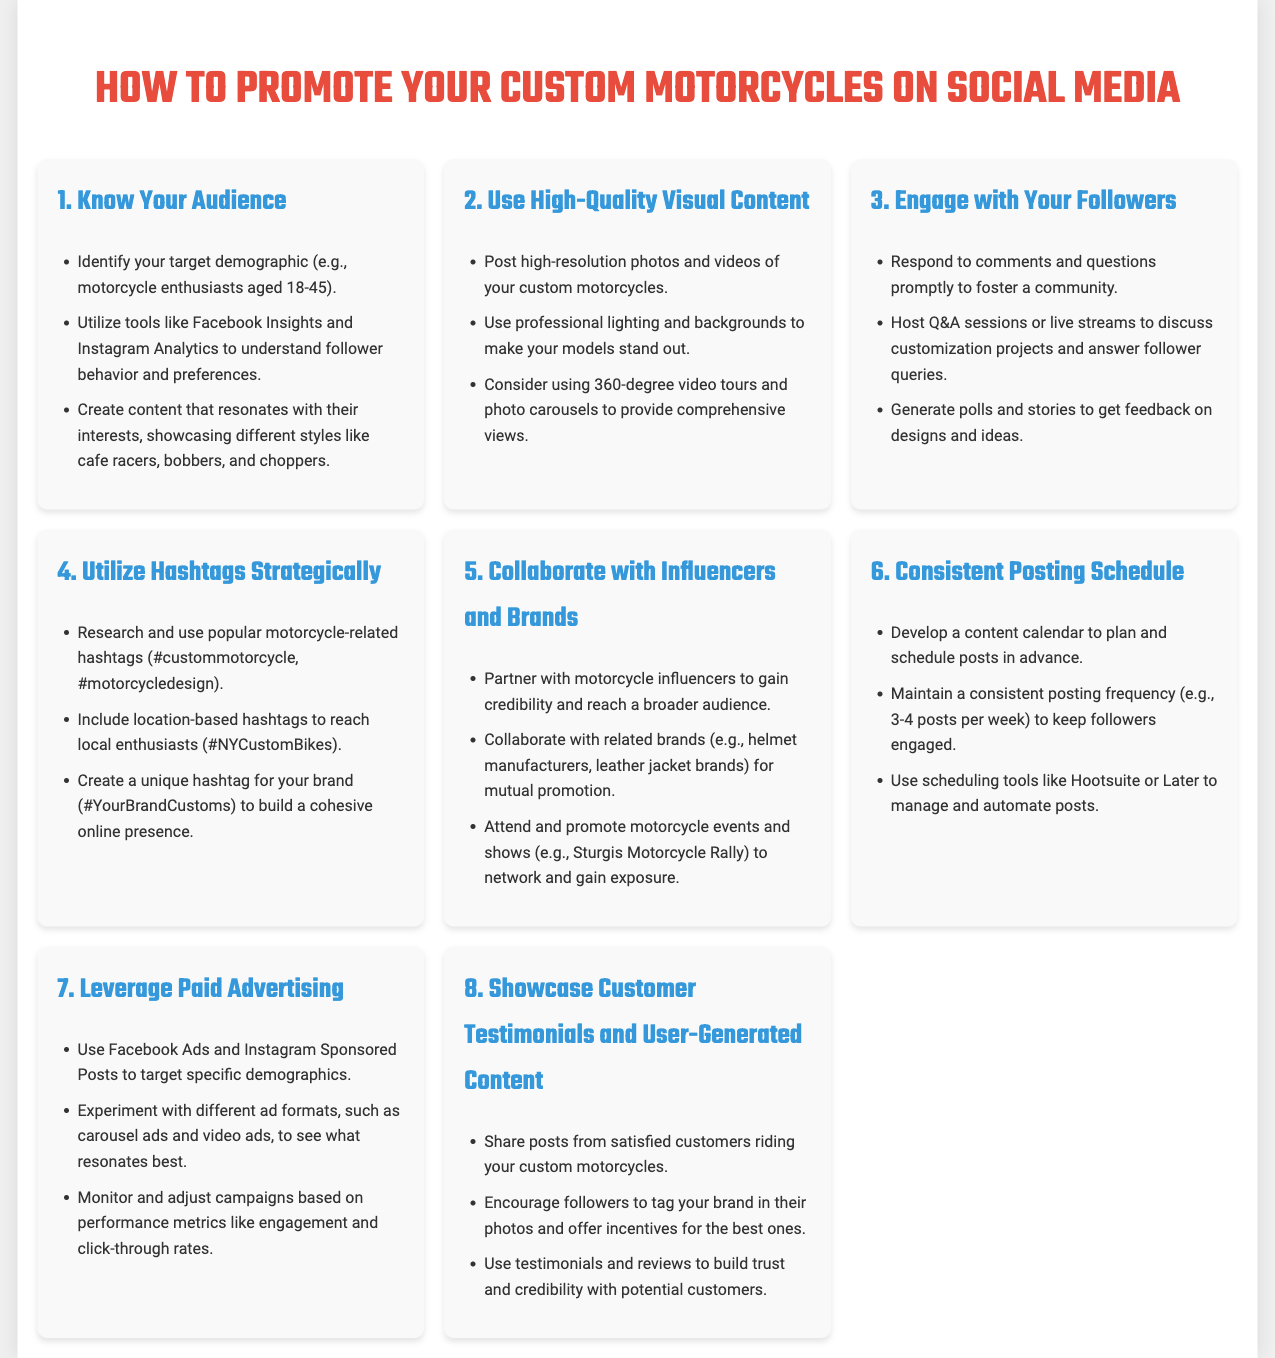What is the first step in promoting custom motorcycles? The first step in the infographic is to "Know Your Audience."
Answer: Know Your Audience How many posts per week does the document recommend for consistent posting? The document suggests maintaining a consistent posting frequency of "3-4 posts per week."
Answer: 3-4 posts per week What type of content should be used according to best practices? The infographic specifies to "Use High-Quality Visual Content."
Answer: Use High-Quality Visual Content Which social media features are recommended for engaging with followers? The document mentions hosting "Q&A sessions or live streams" as a way to engage with followers.
Answer: Q&A sessions or live streams What should be researched when using hashtags? The document advises to research "popular motorcycle-related hashtags."
Answer: popular motorcycle-related hashtags How can you build a cohesive online presence? The infographic suggests creating a "unique hashtag for your brand."
Answer: unique hashtag for your brand What is one method suggested for leveraging paid advertising? The document mentions using "Facebook Ads and Instagram Sponsored Posts" as a method for paid advertising.
Answer: Facebook Ads and Instagram Sponsored Posts Which two categories of content help build trust with potential customers? The document highlights "Customer Testimonials" and "User-Generated Content."
Answer: Customer Testimonials and User-Generated Content 